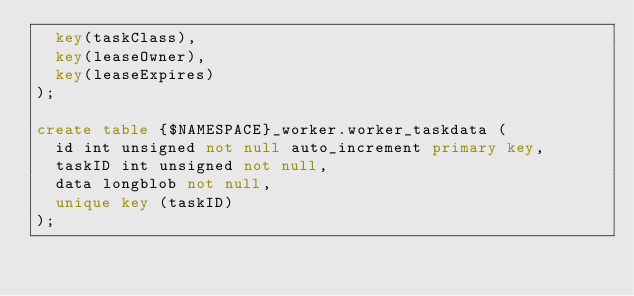<code> <loc_0><loc_0><loc_500><loc_500><_SQL_>  key(taskClass),
  key(leaseOwner),
  key(leaseExpires)
);

create table {$NAMESPACE}_worker.worker_taskdata (
  id int unsigned not null auto_increment primary key,
  taskID int unsigned not null,
  data longblob not null,
  unique key (taskID)
);
</code> 